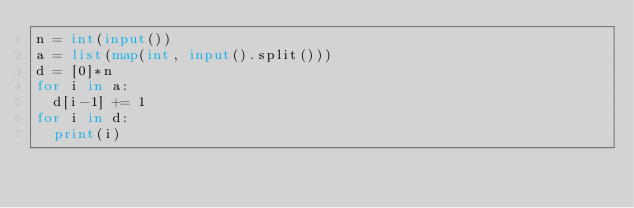<code> <loc_0><loc_0><loc_500><loc_500><_Python_>n = int(input())
a = list(map(int, input().split()))
d = [0]*n
for i in a:
  d[i-1] += 1
for i in d:
  print(i)</code> 